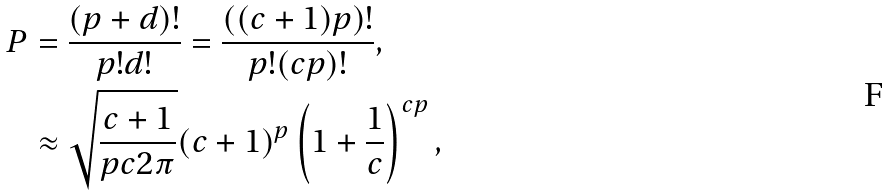Convert formula to latex. <formula><loc_0><loc_0><loc_500><loc_500>P & = \frac { ( p + d ) ! } { p ! d ! } = \frac { ( ( c + 1 ) p ) ! } { p ! ( c p ) ! } , \\ & \approx \sqrt { \frac { c + 1 } { p c 2 \pi } } ( c + 1 ) ^ { p } \left ( 1 + \frac { 1 } { c } \right ) ^ { c p } ,</formula> 